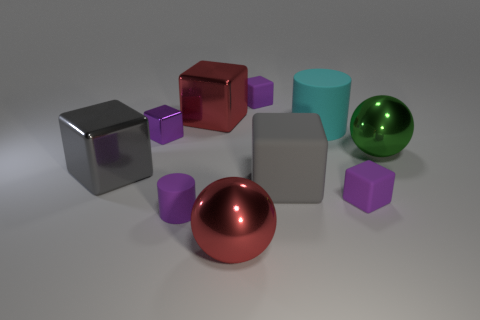Subtract all blue cylinders. How many purple cubes are left? 3 Subtract all gray cubes. How many cubes are left? 4 Subtract all big gray matte blocks. How many blocks are left? 5 Subtract all green blocks. Subtract all red cylinders. How many blocks are left? 6 Subtract all balls. How many objects are left? 8 Subtract all red spheres. Subtract all big green shiny spheres. How many objects are left? 8 Add 4 cyan cylinders. How many cyan cylinders are left? 5 Add 7 green objects. How many green objects exist? 8 Subtract 0 gray spheres. How many objects are left? 10 